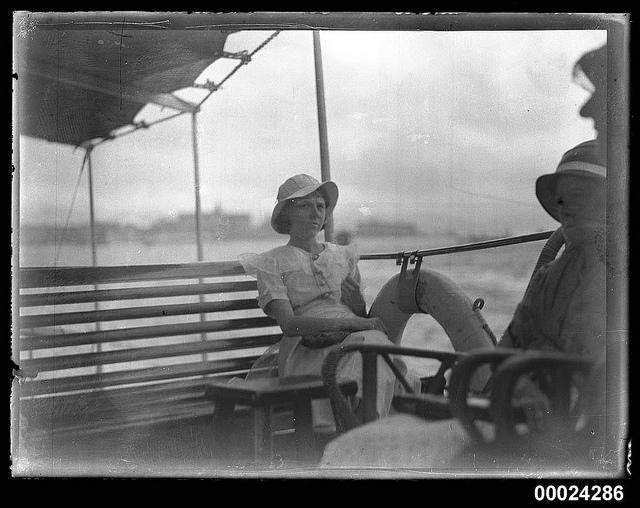How many people are there?
Give a very brief answer. 3. 